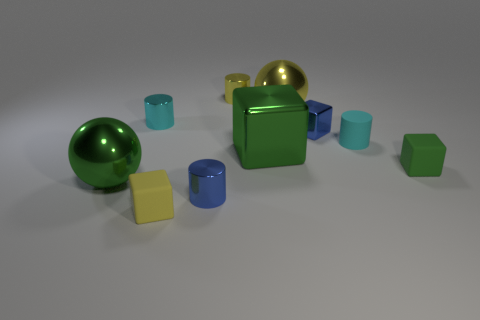What materials are the objects in the image made of? The objects in the image appear to have various materials. The sphere and the cube are metallic, exhibiting reflective surfaces. The other objects seem to have a matte finish, suggesting they might be made of plastic or rubber. 